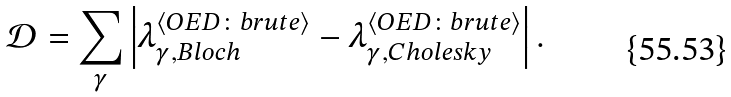<formula> <loc_0><loc_0><loc_500><loc_500>\mathcal { D } = \sum _ { \gamma } \left | \lambda ^ { \langle O E D \colon b r u t e \rangle } _ { \gamma , B l o c h } - \lambda ^ { \langle O E D \colon b r u t e \rangle } _ { \gamma , C h o l e s k y } \right | .</formula> 